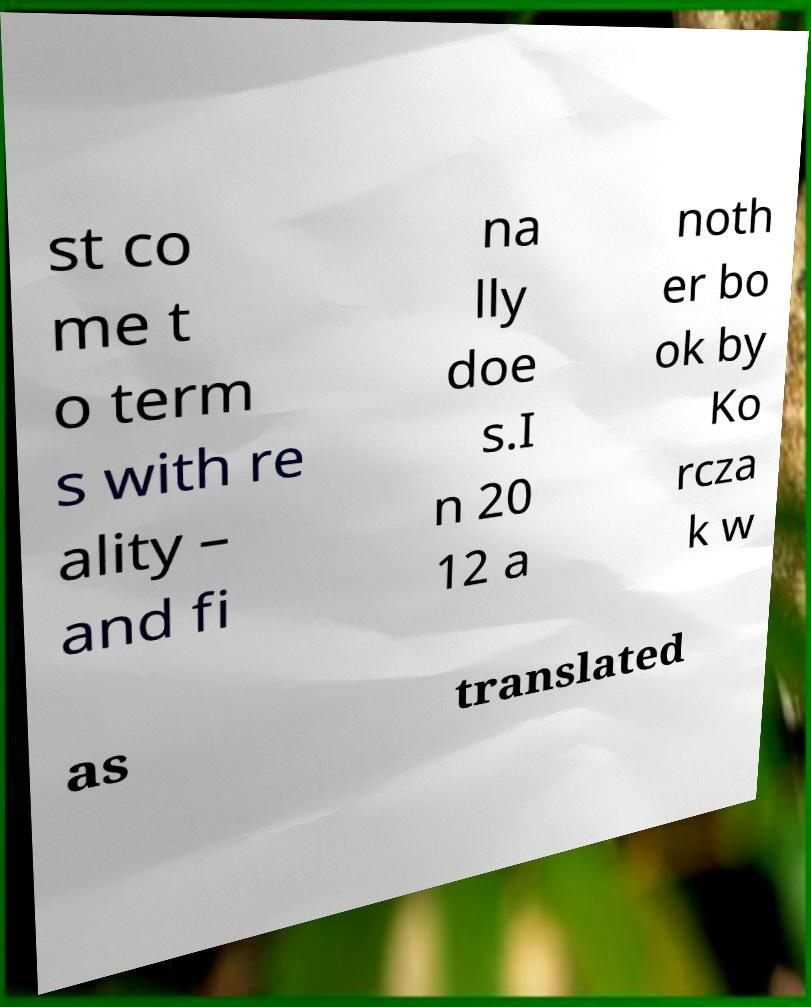For documentation purposes, I need the text within this image transcribed. Could you provide that? st co me t o term s with re ality – and fi na lly doe s.I n 20 12 a noth er bo ok by Ko rcza k w as translated 